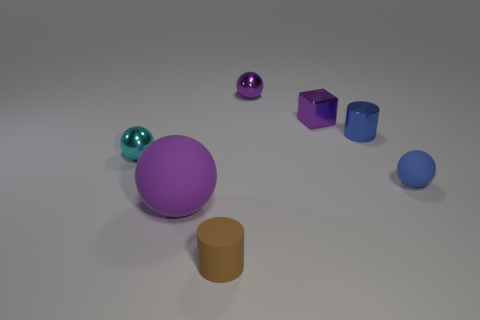Add 2 tiny metallic spheres. How many objects exist? 9 Subtract all cubes. How many objects are left? 6 Add 2 shiny cylinders. How many shiny cylinders are left? 3 Add 7 small blue things. How many small blue things exist? 9 Subtract 0 yellow blocks. How many objects are left? 7 Subtract all cyan metallic objects. Subtract all rubber objects. How many objects are left? 3 